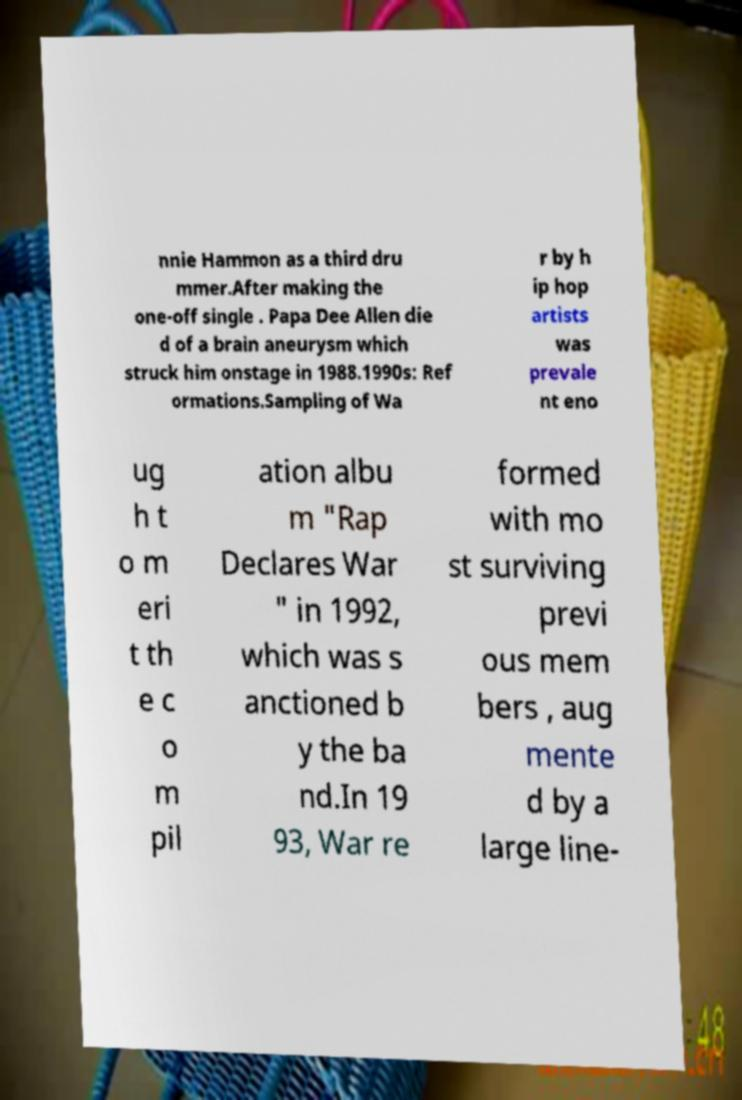I need the written content from this picture converted into text. Can you do that? nnie Hammon as a third dru mmer.After making the one-off single . Papa Dee Allen die d of a brain aneurysm which struck him onstage in 1988.1990s: Ref ormations.Sampling of Wa r by h ip hop artists was prevale nt eno ug h t o m eri t th e c o m pil ation albu m "Rap Declares War " in 1992, which was s anctioned b y the ba nd.In 19 93, War re formed with mo st surviving previ ous mem bers , aug mente d by a large line- 